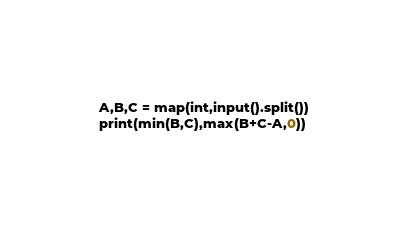<code> <loc_0><loc_0><loc_500><loc_500><_Python_>A,B,C = map(int,input().split())
print(min(B,C),max(B+C-A,0))</code> 